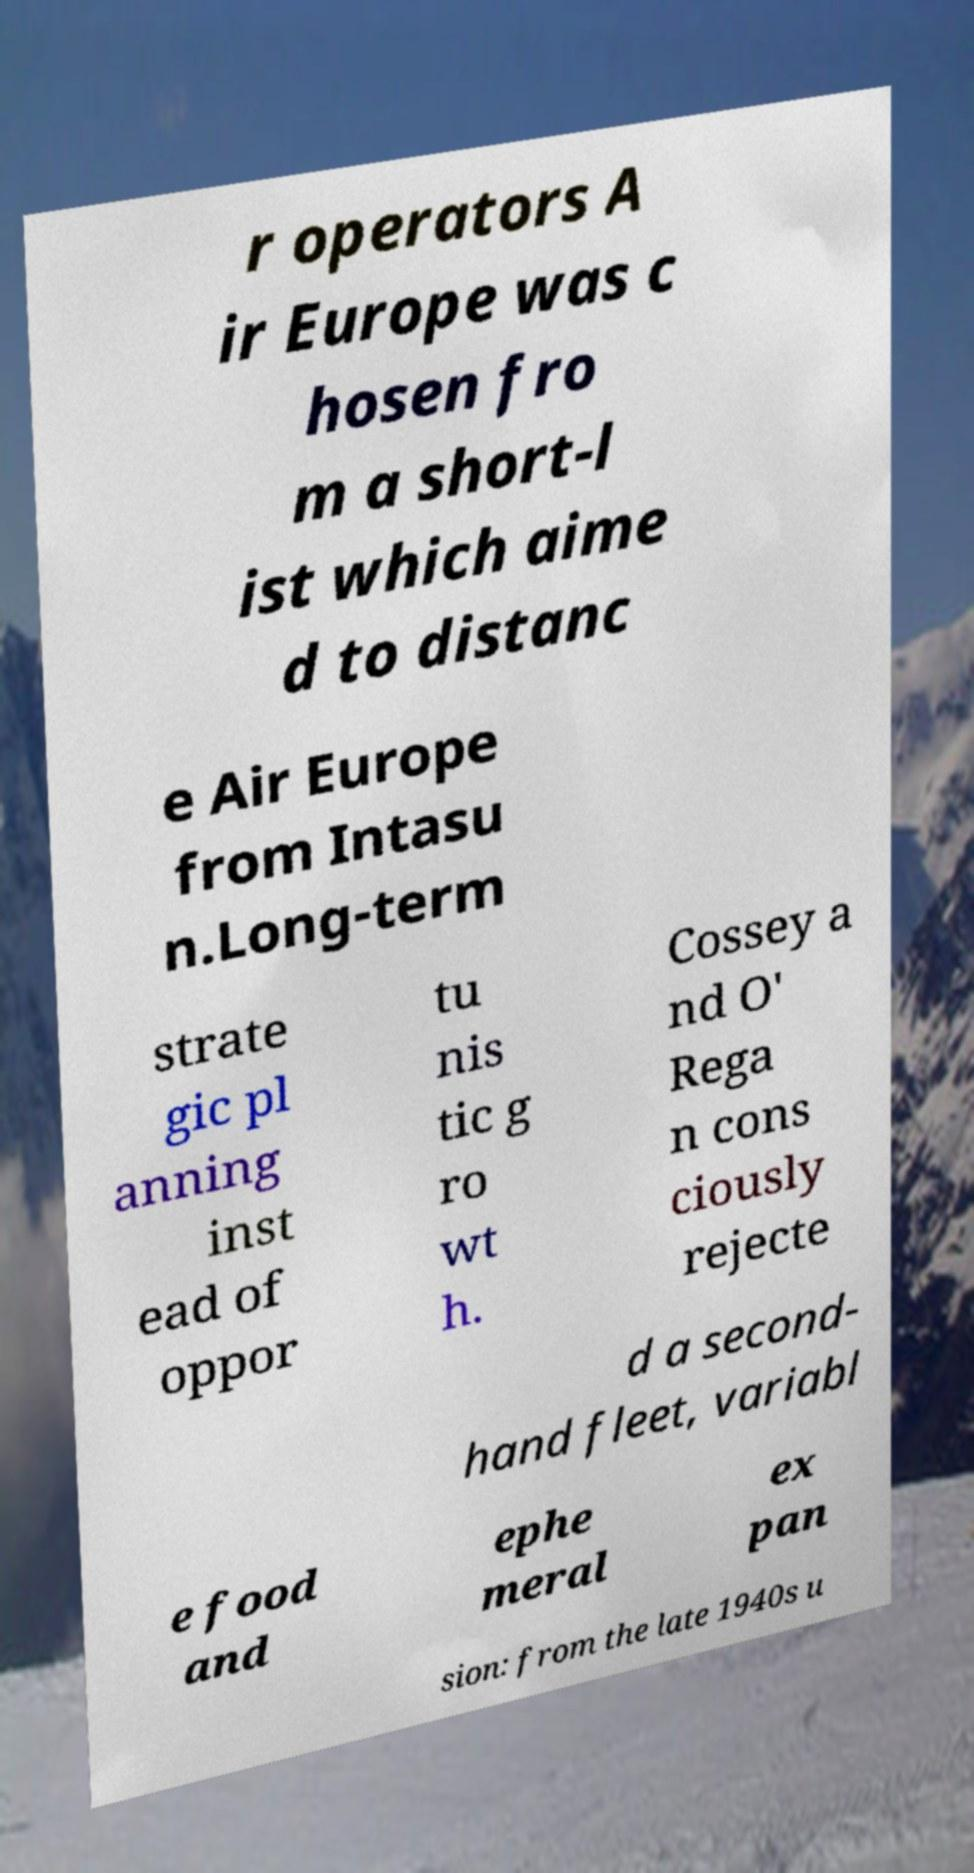Could you assist in decoding the text presented in this image and type it out clearly? r operators A ir Europe was c hosen fro m a short-l ist which aime d to distanc e Air Europe from Intasu n.Long-term strate gic pl anning inst ead of oppor tu nis tic g ro wt h. Cossey a nd O' Rega n cons ciously rejecte d a second- hand fleet, variabl e food and ephe meral ex pan sion: from the late 1940s u 